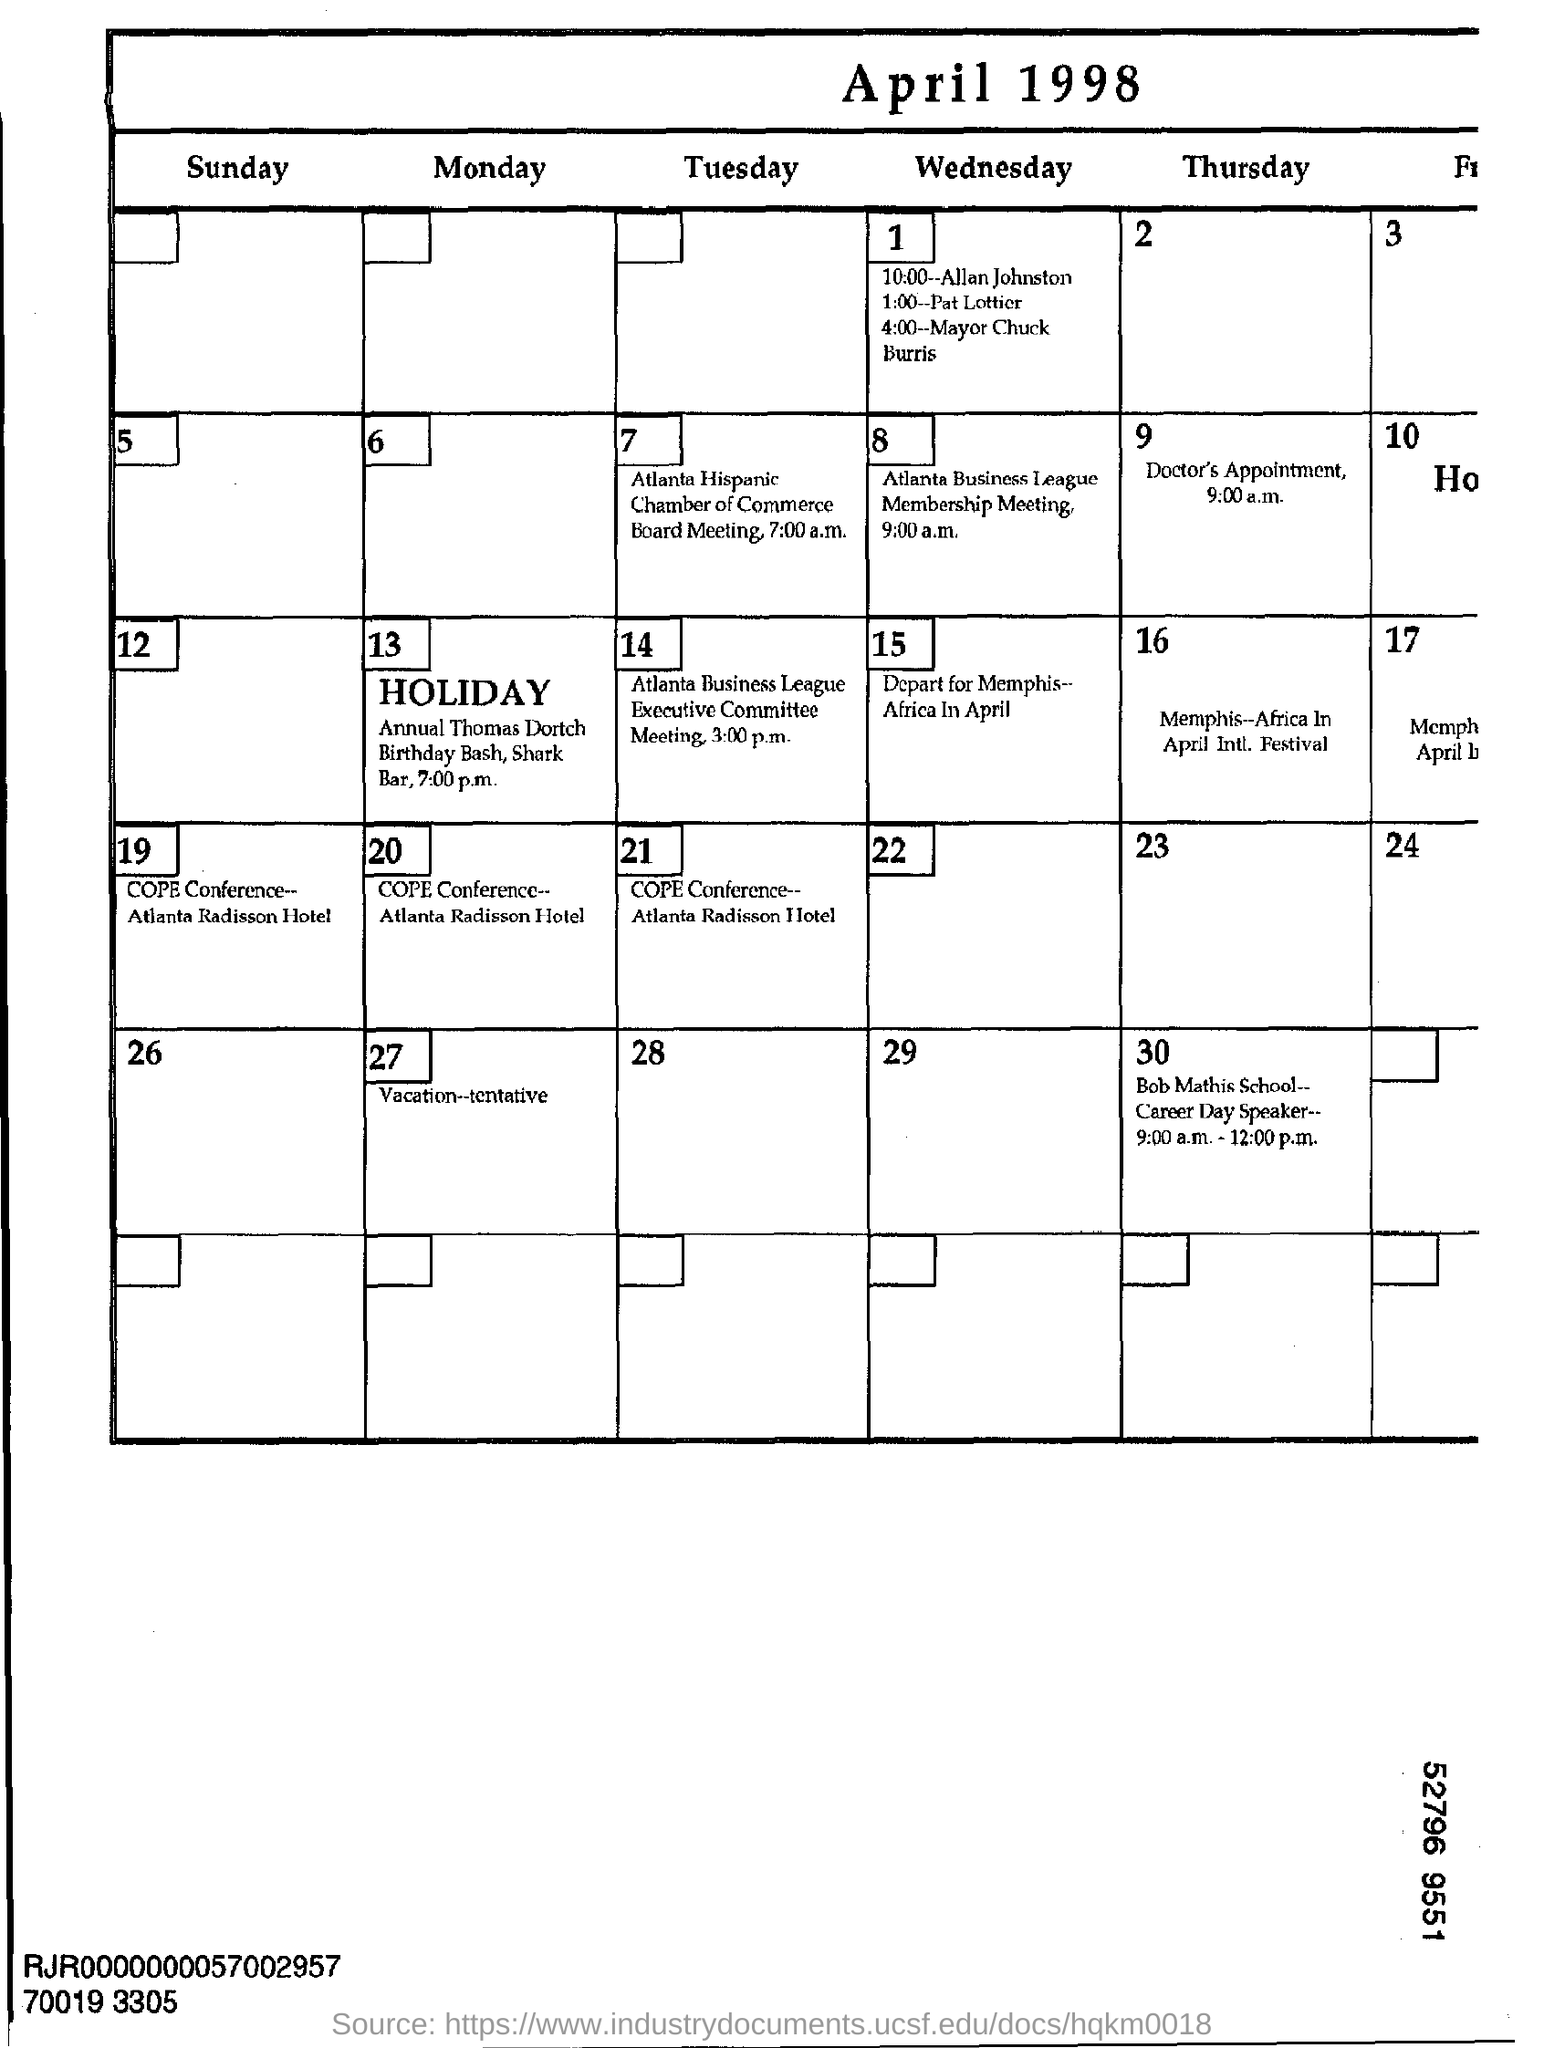Mention a couple of crucial points in this snapshot. The Atlanta Hispanic Chamber of Commerce Board meeting will commence at 7:00 a.m. on Thursday, January 26, 2023. The Atlanta Business League Membership meeting is scheduled to begin at 9:00 a.m. The timing of the Atlanta Hispanic Chamber of Commerce Board meeting is 7:00 a.m. The timing of the Atlanta Business League Membership meeting is 9:00 a.m. 